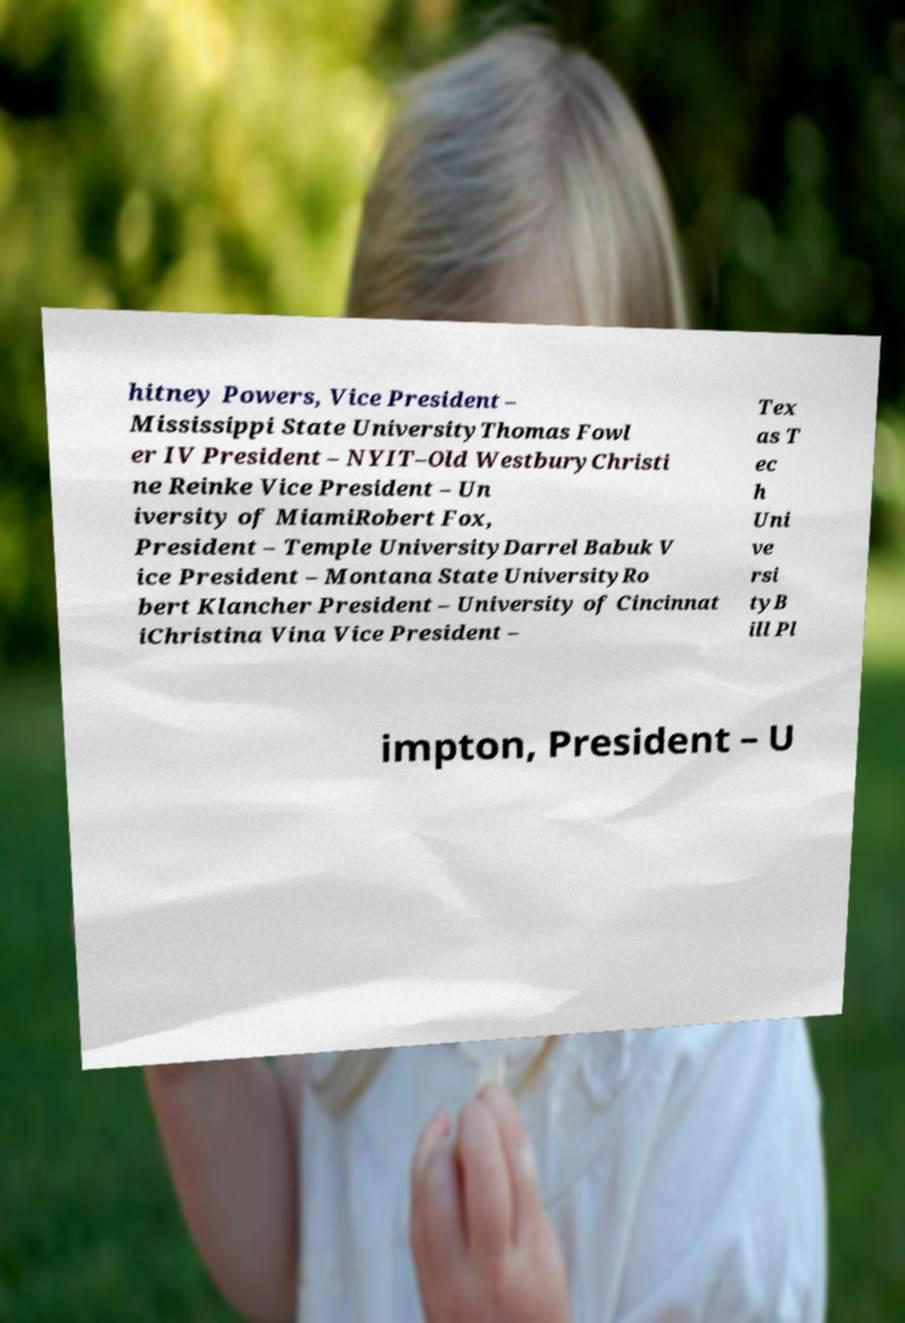Could you extract and type out the text from this image? hitney Powers, Vice President – Mississippi State UniversityThomas Fowl er IV President – NYIT–Old WestburyChristi ne Reinke Vice President – Un iversity of MiamiRobert Fox, President – Temple UniversityDarrel Babuk V ice President – Montana State UniversityRo bert Klancher President – University of Cincinnat iChristina Vina Vice President – Tex as T ec h Uni ve rsi tyB ill Pl impton, President – U 